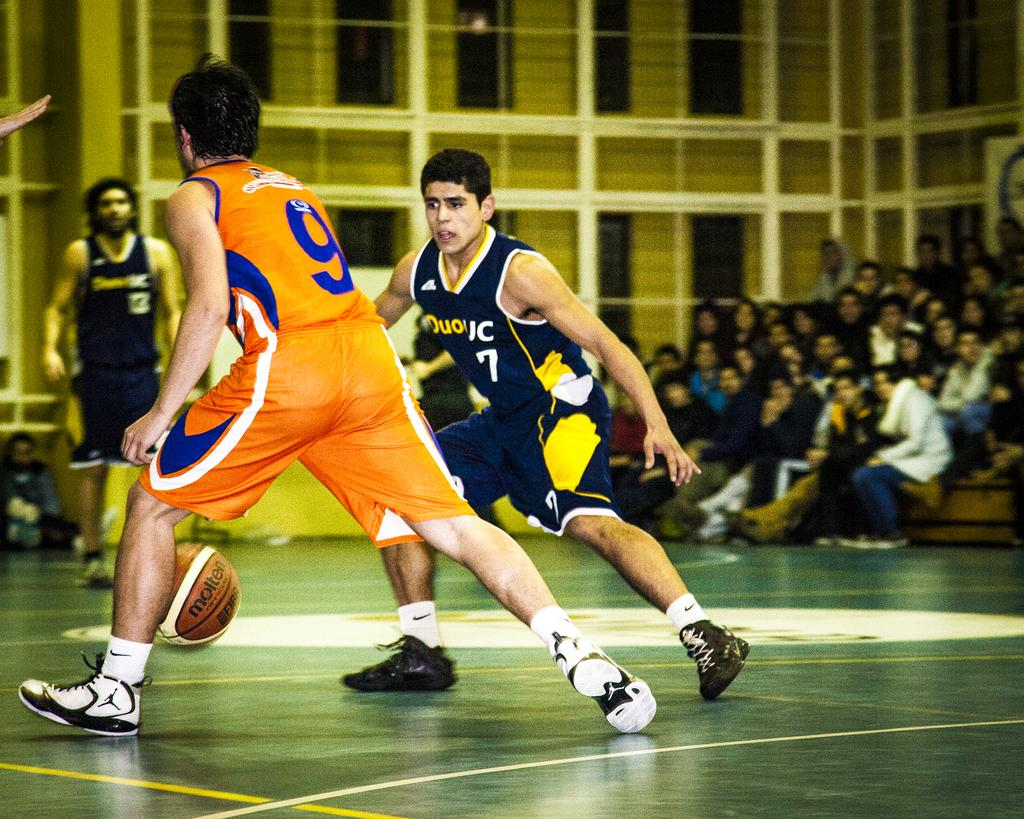Provide a one-sentence caption for the provided image. The basketball player with the number 9 on his jersey on has the ball. 